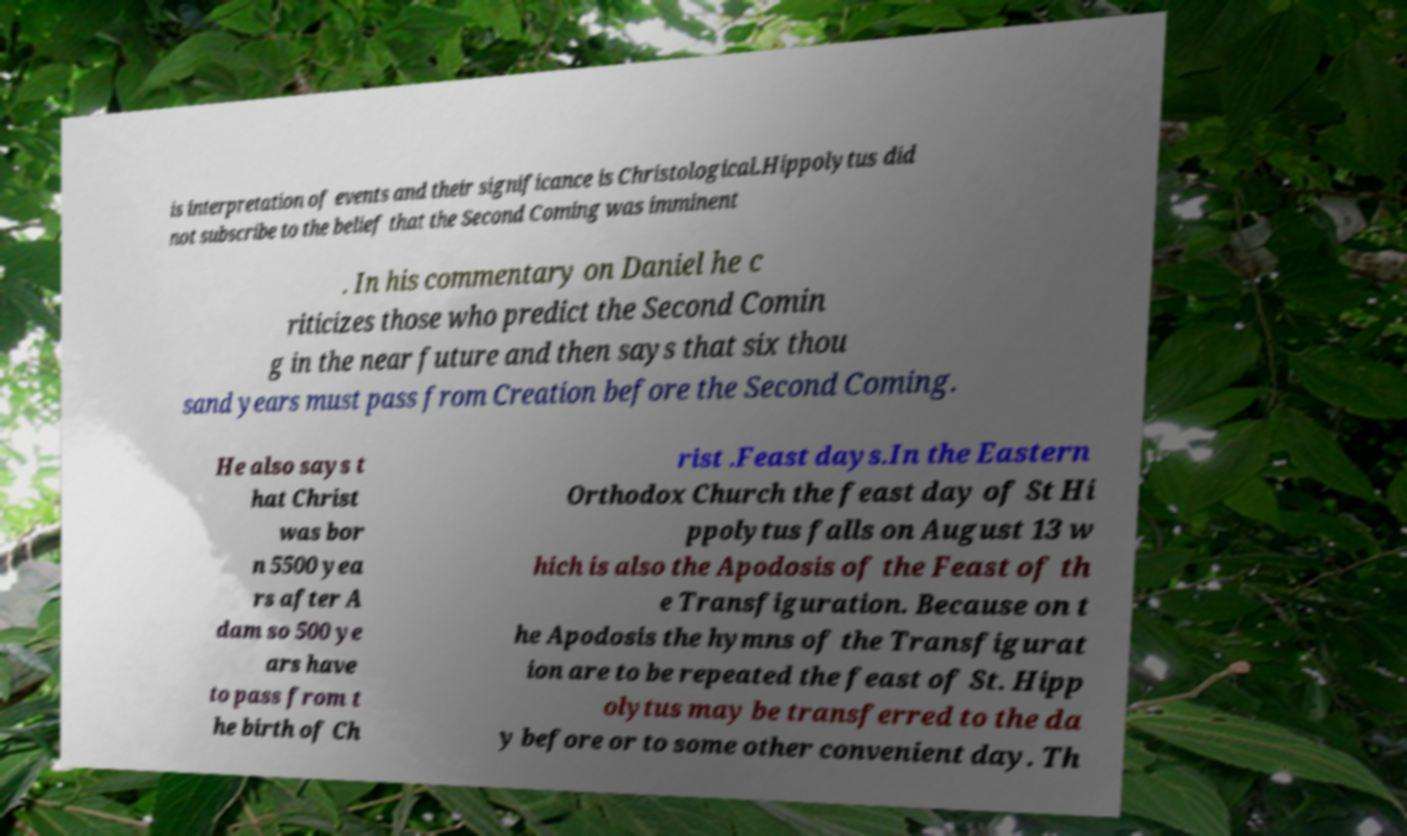Please read and relay the text visible in this image. What does it say? is interpretation of events and their significance is Christological.Hippolytus did not subscribe to the belief that the Second Coming was imminent . In his commentary on Daniel he c riticizes those who predict the Second Comin g in the near future and then says that six thou sand years must pass from Creation before the Second Coming. He also says t hat Christ was bor n 5500 yea rs after A dam so 500 ye ars have to pass from t he birth of Ch rist .Feast days.In the Eastern Orthodox Church the feast day of St Hi ppolytus falls on August 13 w hich is also the Apodosis of the Feast of th e Transfiguration. Because on t he Apodosis the hymns of the Transfigurat ion are to be repeated the feast of St. Hipp olytus may be transferred to the da y before or to some other convenient day. Th 